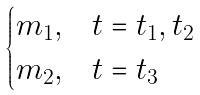Convert formula to latex. <formula><loc_0><loc_0><loc_500><loc_500>\begin{cases} m _ { 1 } , & t = t _ { 1 } , t _ { 2 } \\ m _ { 2 } , & t = t _ { 3 } \end{cases}</formula> 